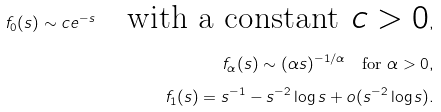<formula> <loc_0><loc_0><loc_500><loc_500>f _ { 0 } ( s ) \sim c e ^ { - s } \quad \text {with a constant $c>0$} , \\ f _ { \alpha } ( s ) \sim ( \alpha s ) ^ { - 1 / \alpha } \quad \text {for $\alpha>0$} , \\ f _ { 1 } ( s ) = s ^ { - 1 } - s ^ { - 2 } \log s + o ( s ^ { - 2 } \log s ) .</formula> 